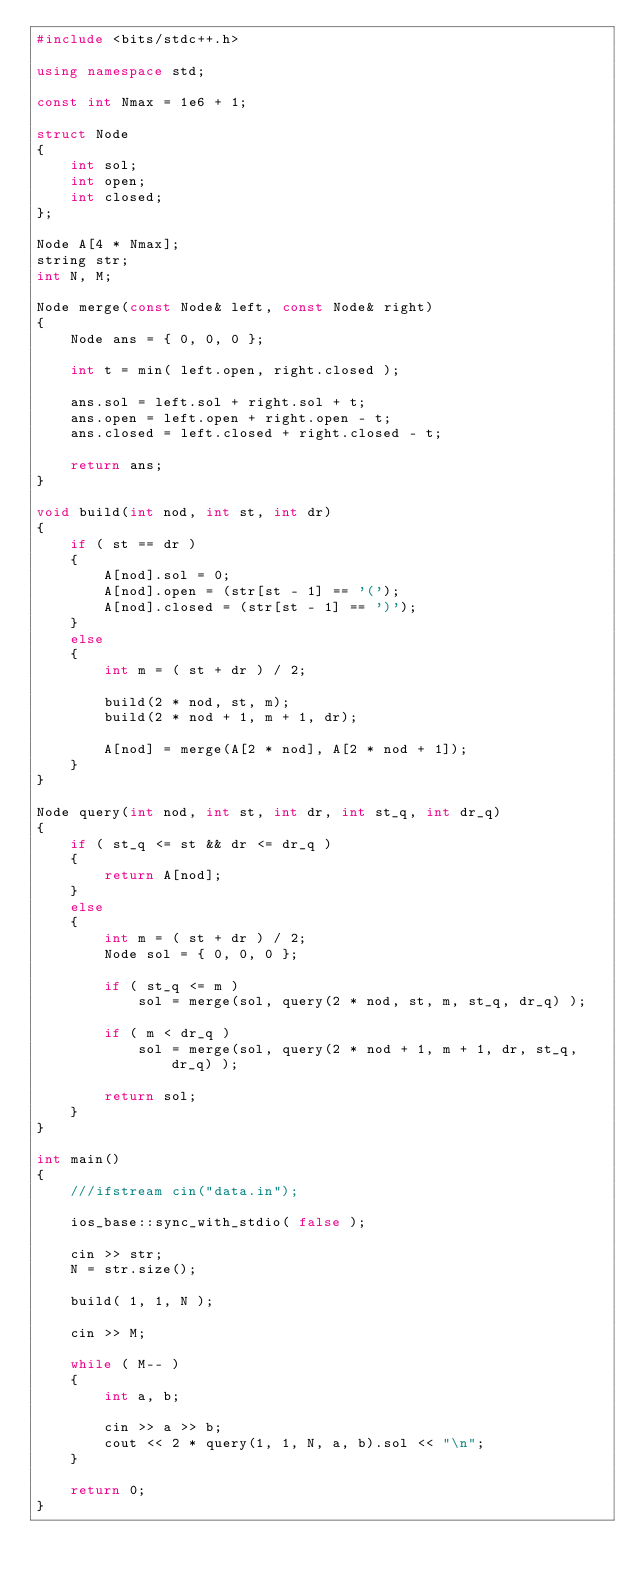<code> <loc_0><loc_0><loc_500><loc_500><_C++_>#include <bits/stdc++.h>

using namespace std;

const int Nmax = 1e6 + 1;

struct Node
{
    int sol;
    int open;
    int closed;
};

Node A[4 * Nmax];
string str;
int N, M;

Node merge(const Node& left, const Node& right)
{
    Node ans = { 0, 0, 0 };

    int t = min( left.open, right.closed );

    ans.sol = left.sol + right.sol + t;
    ans.open = left.open + right.open - t;
    ans.closed = left.closed + right.closed - t;

    return ans;
}

void build(int nod, int st, int dr)
{
    if ( st == dr )
    {
        A[nod].sol = 0;
        A[nod].open = (str[st - 1] == '(');
        A[nod].closed = (str[st - 1] == ')');
    }
    else
    {
        int m = ( st + dr ) / 2;

        build(2 * nod, st, m);
        build(2 * nod + 1, m + 1, dr);

        A[nod] = merge(A[2 * nod], A[2 * nod + 1]);
    }
}

Node query(int nod, int st, int dr, int st_q, int dr_q)
{
    if ( st_q <= st && dr <= dr_q )
    {
        return A[nod];
    }
    else
    {
        int m = ( st + dr ) / 2;
        Node sol = { 0, 0, 0 };

        if ( st_q <= m )
            sol = merge(sol, query(2 * nod, st, m, st_q, dr_q) );

        if ( m < dr_q )
            sol = merge(sol, query(2 * nod + 1, m + 1, dr, st_q, dr_q) );

        return sol;
    }
}

int main()
{
    ///ifstream cin("data.in");

    ios_base::sync_with_stdio( false );

    cin >> str;
    N = str.size();

    build( 1, 1, N );

    cin >> M;

    while ( M-- )
    {
        int a, b;

        cin >> a >> b;
        cout << 2 * query(1, 1, N, a, b).sol << "\n";
    }

    return 0;
}
</code> 